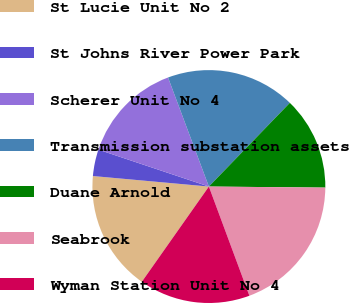Convert chart to OTSL. <chart><loc_0><loc_0><loc_500><loc_500><pie_chart><fcel>St Lucie Unit No 2<fcel>St Johns River Power Park<fcel>Scherer Unit No 4<fcel>Transmission substation assets<fcel>Duane Arnold<fcel>Seabrook<fcel>Wyman Station Unit No 4<nl><fcel>16.68%<fcel>3.69%<fcel>14.17%<fcel>17.94%<fcel>12.91%<fcel>19.2%<fcel>15.42%<nl></chart> 